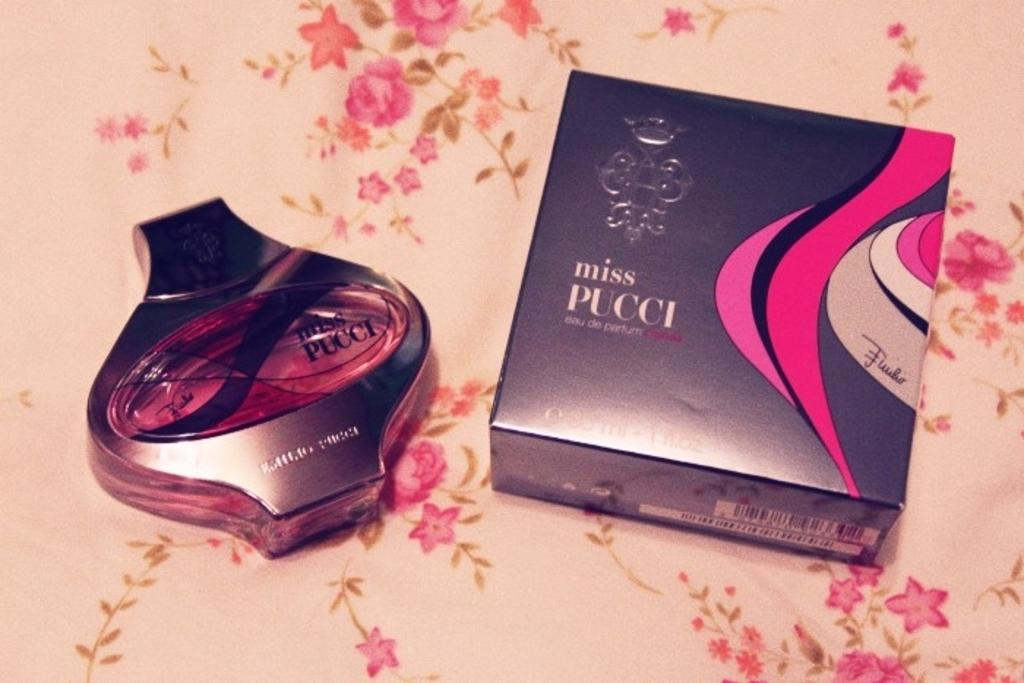<image>
Describe the image concisely. A bottle sits next to a Miss Pucci bottle. 